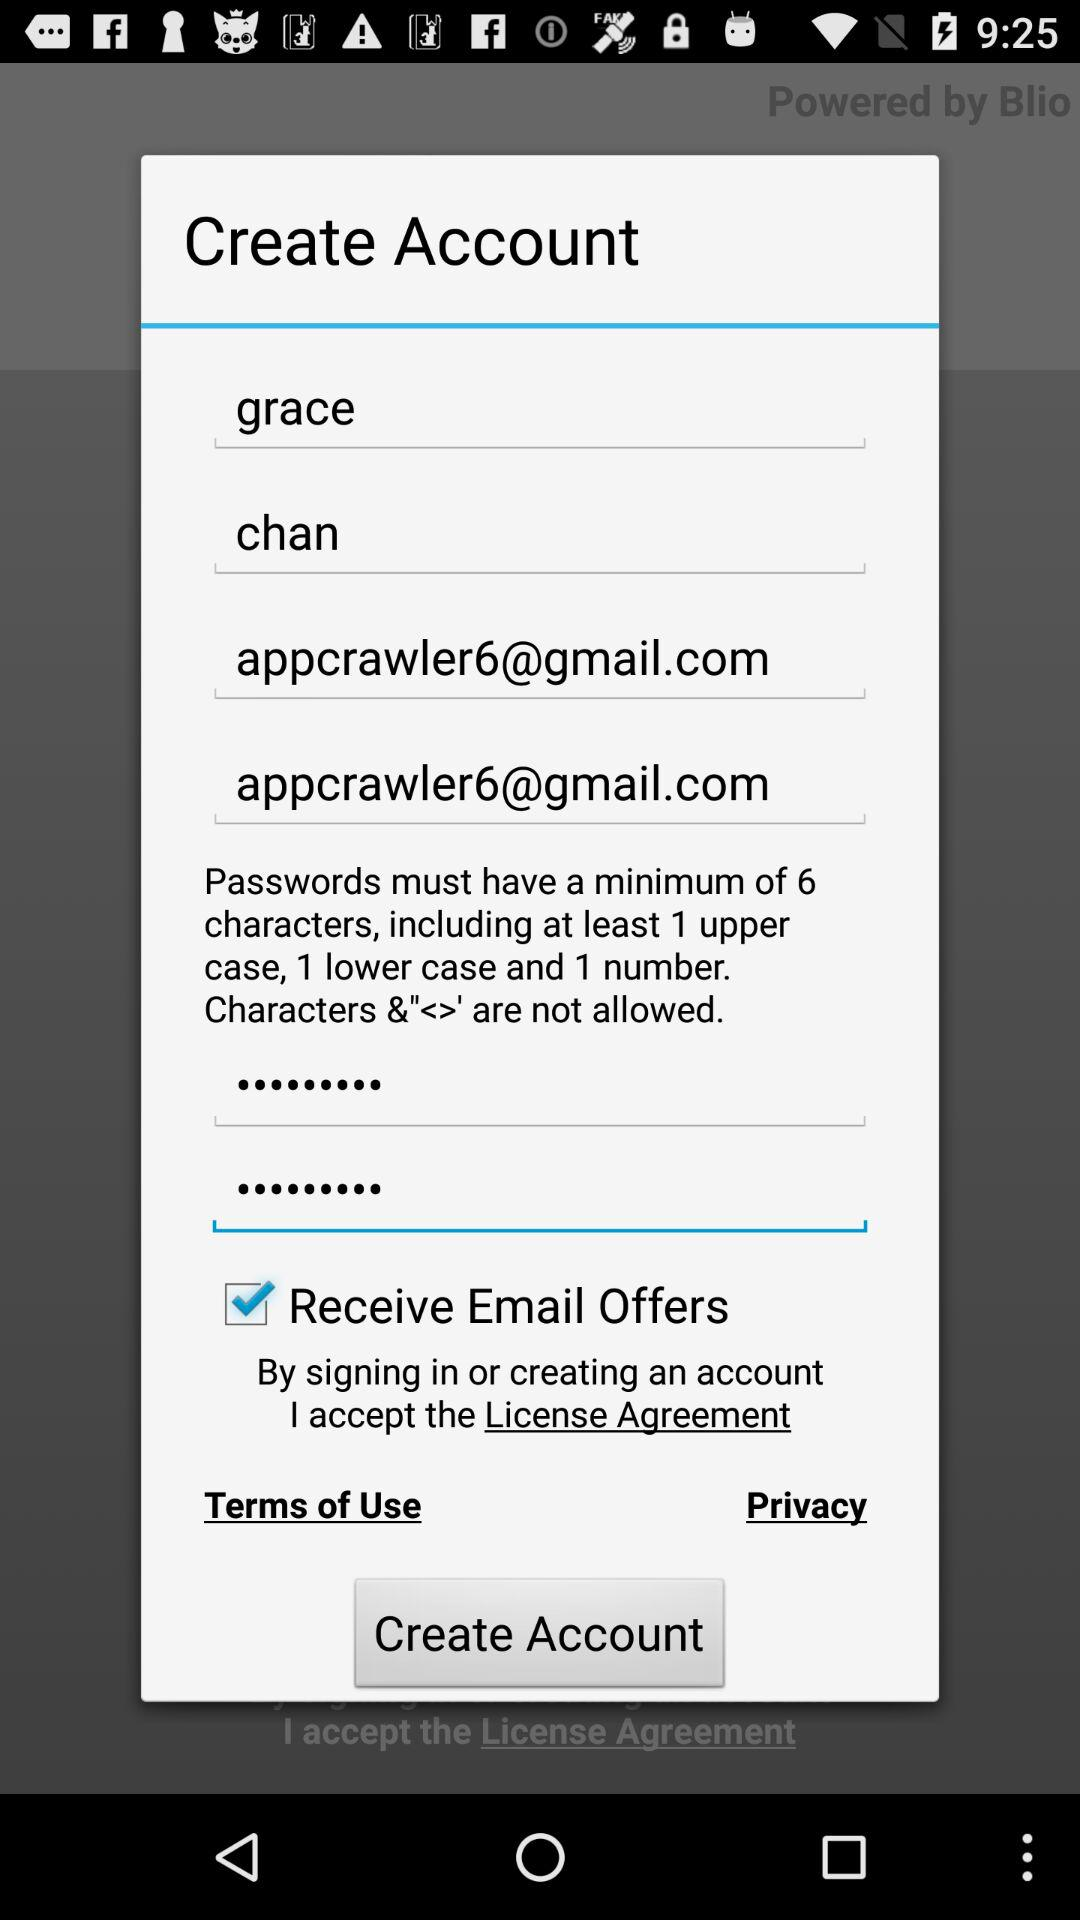What characters are not allowed? The disallowed characters are &"<>'. 